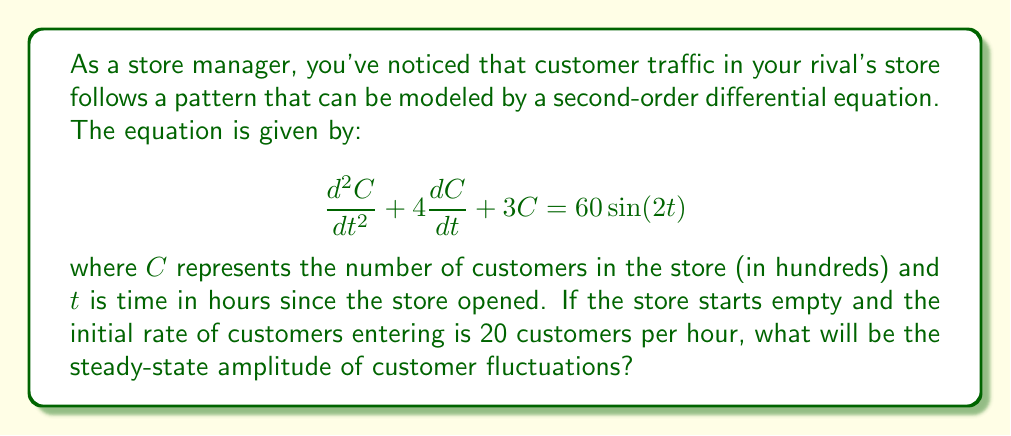Teach me how to tackle this problem. To solve this problem, we need to follow these steps:

1) First, recognize that this is a forced oscillation problem with a sinusoidal forcing function.

2) The general form of such an equation is:

   $$\frac{d^2x}{dt^2} + 2\zeta\omega_n\frac{dx}{dt} + \omega_n^2x = F_0\sin(\omega t)$$

3) Comparing our equation to this general form, we can identify:
   
   $2\zeta\omega_n = 4$
   $\omega_n^2 = 3$
   $F_0 = 60$
   $\omega = 2$

4) The steady-state solution for such a system has the form:

   $$C_{ss}(t) = A\sin(2t - \phi)$$

   where $A$ is the amplitude we're looking for.

5) The amplitude $A$ is given by the formula:

   $$A = \frac{F_0}{\sqrt{(\omega_n^2 - \omega^2)^2 + (2\zeta\omega_n\omega)^2}}$$

6) We can calculate $\omega_n = \sqrt{3}$ and $\zeta = \frac{2}{\sqrt{3}}$

7) Substituting these values:

   $$A = \frac{60}{\sqrt{(3 - 4)^2 + (4 \cdot 2)^2}} = \frac{60}{\sqrt{1 + 64}} = \frac{60}{\sqrt{65}}$$

8) This amplitude represents hundreds of customers, so we need to multiply by 100 to get the actual number of customers.

Therefore, the steady-state amplitude of customer fluctuations is $\frac{6000}{\sqrt{65}}$ customers.
Answer: $\frac{6000}{\sqrt{65}} \approx 744$ customers 